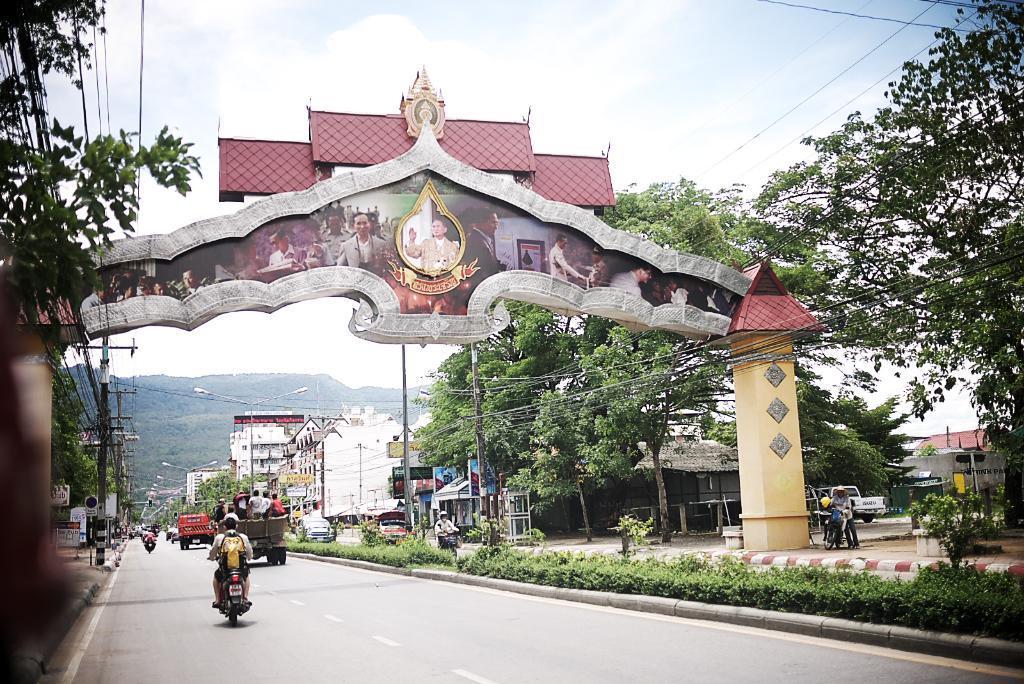Can you describe this image briefly? In the image there are few vehicles on the road and there is an arch, there are some pictures on the arch, there are many trees, buildings and street lights. There are few current poles on the left side, in the background there are mountains. 